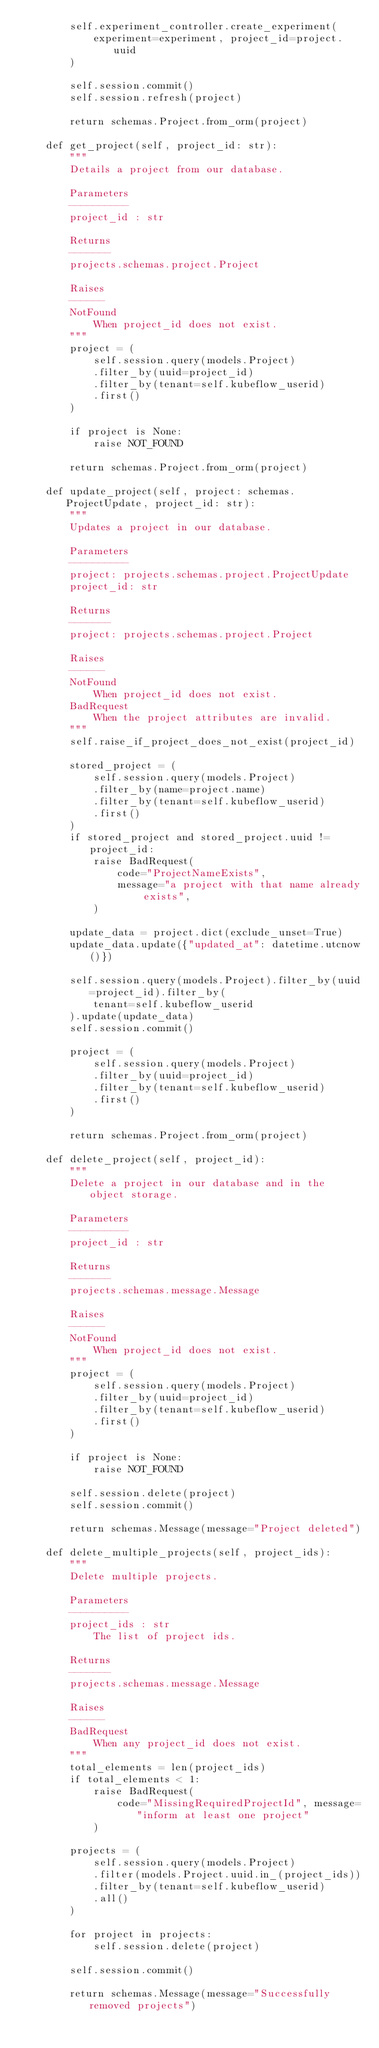<code> <loc_0><loc_0><loc_500><loc_500><_Python_>        self.experiment_controller.create_experiment(
            experiment=experiment, project_id=project.uuid
        )

        self.session.commit()
        self.session.refresh(project)

        return schemas.Project.from_orm(project)

    def get_project(self, project_id: str):
        """
        Details a project from our database.

        Parameters
        ----------
        project_id : str

        Returns
        -------
        projects.schemas.project.Project

        Raises
        ------
        NotFound
            When project_id does not exist.
        """
        project = (
            self.session.query(models.Project)
            .filter_by(uuid=project_id)
            .filter_by(tenant=self.kubeflow_userid)
            .first()
        )

        if project is None:
            raise NOT_FOUND

        return schemas.Project.from_orm(project)

    def update_project(self, project: schemas.ProjectUpdate, project_id: str):
        """
        Updates a project in our database.

        Parameters
        ----------
        project: projects.schemas.project.ProjectUpdate
        project_id: str

        Returns
        -------
        project: projects.schemas.project.Project

        Raises
        ------
        NotFound
            When project_id does not exist.
        BadRequest
            When the project attributes are invalid.
        """
        self.raise_if_project_does_not_exist(project_id)

        stored_project = (
            self.session.query(models.Project)
            .filter_by(name=project.name)
            .filter_by(tenant=self.kubeflow_userid)
            .first()
        )
        if stored_project and stored_project.uuid != project_id:
            raise BadRequest(
                code="ProjectNameExists",
                message="a project with that name already exists",
            )

        update_data = project.dict(exclude_unset=True)
        update_data.update({"updated_at": datetime.utcnow()})

        self.session.query(models.Project).filter_by(uuid=project_id).filter_by(
            tenant=self.kubeflow_userid
        ).update(update_data)
        self.session.commit()

        project = (
            self.session.query(models.Project)
            .filter_by(uuid=project_id)
            .filter_by(tenant=self.kubeflow_userid)
            .first()
        )

        return schemas.Project.from_orm(project)

    def delete_project(self, project_id):
        """
        Delete a project in our database and in the object storage.

        Parameters
        ----------
        project_id : str

        Returns
        -------
        projects.schemas.message.Message

        Raises
        ------
        NotFound
            When project_id does not exist.
        """
        project = (
            self.session.query(models.Project)
            .filter_by(uuid=project_id)
            .filter_by(tenant=self.kubeflow_userid)
            .first()
        )

        if project is None:
            raise NOT_FOUND

        self.session.delete(project)
        self.session.commit()

        return schemas.Message(message="Project deleted")

    def delete_multiple_projects(self, project_ids):
        """
        Delete multiple projects.

        Parameters
        ----------
        project_ids : str
            The list of project ids.

        Returns
        -------
        projects.schemas.message.Message

        Raises
        ------
        BadRequest
            When any project_id does not exist.
        """
        total_elements = len(project_ids)
        if total_elements < 1:
            raise BadRequest(
                code="MissingRequiredProjectId", message="inform at least one project"
            )

        projects = (
            self.session.query(models.Project)
            .filter(models.Project.uuid.in_(project_ids))
            .filter_by(tenant=self.kubeflow_userid)
            .all()
        )

        for project in projects:
            self.session.delete(project)

        self.session.commit()

        return schemas.Message(message="Successfully removed projects")
</code> 